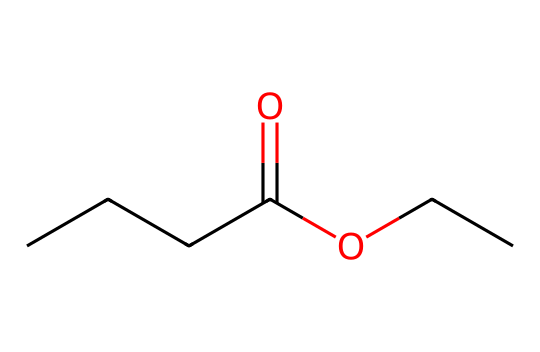What is the chemical name of the compound represented by the SMILES? The SMILES indicates that the compound consists of an ester functional group (–O–) adjacent to an alkyl chain (ethyl) and a butanoate. This leads to the name ethyl butyrate.
Answer: ethyl butyrate How many carbon atoms are present in ethyl butyrate? Counting the carbon atoms in the structure, there are a total of 6 carbon atoms: 4 from the butanoate part and 2 from the ethyl group.
Answer: 6 What type of functional group is present in ethyl butyrate? The presence of the –COO– group indicates that the compound is an ester, as it contains the characteristic ester functional group.
Answer: ester What is the degree of unsaturation in ethyl butyrate? The structure contains only single bonds and no rings or double bonds, which suggests it has a degree of unsaturation of 0.
Answer: 0 Which part of the chemical structure contributes to its fruity aroma? The ester functional group (–COO–) is responsible for the fruity aroma, common to many esters, indicating a pleasant smell often associated with fruits.
Answer: ester How many oxygen atoms are in ethyl butyrate? Looking at the structure, there are 2 oxygen atoms present: one in the carbonyl group (C=O) and another in the ether part (–O–).
Answer: 2 What is the boiling point trend of esters compared to alcohols? Generally, esters have lower boiling points than alcohols with similar molecular weights due to the absence of hydrogen bonding in esters compared to alcohols.
Answer: lower 